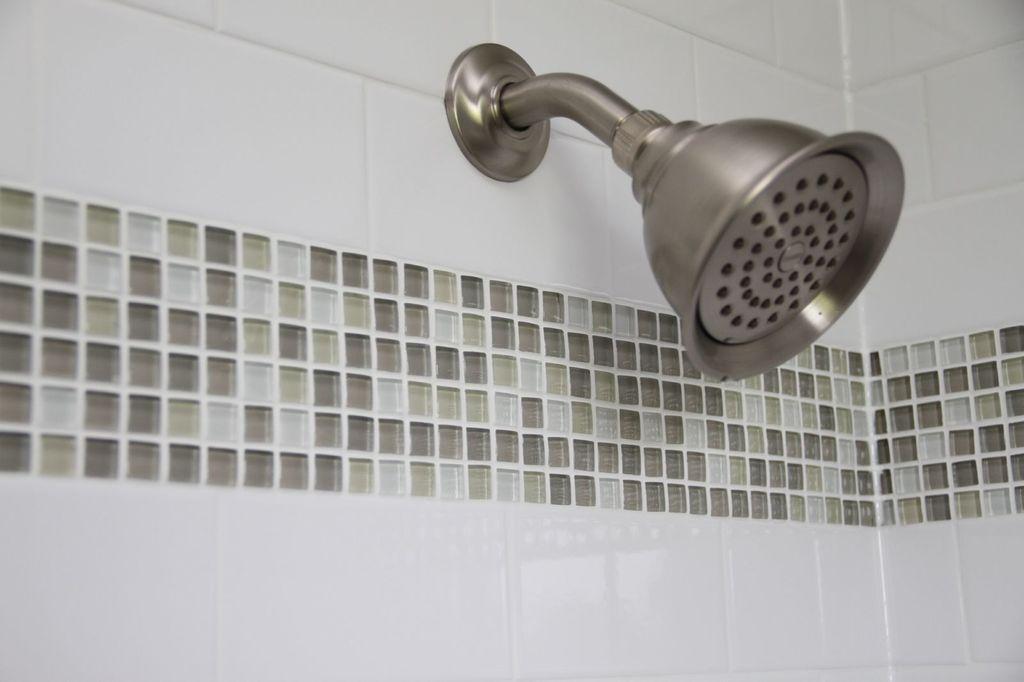Describe this image in one or two sentences. We can see shower, road and wall. 